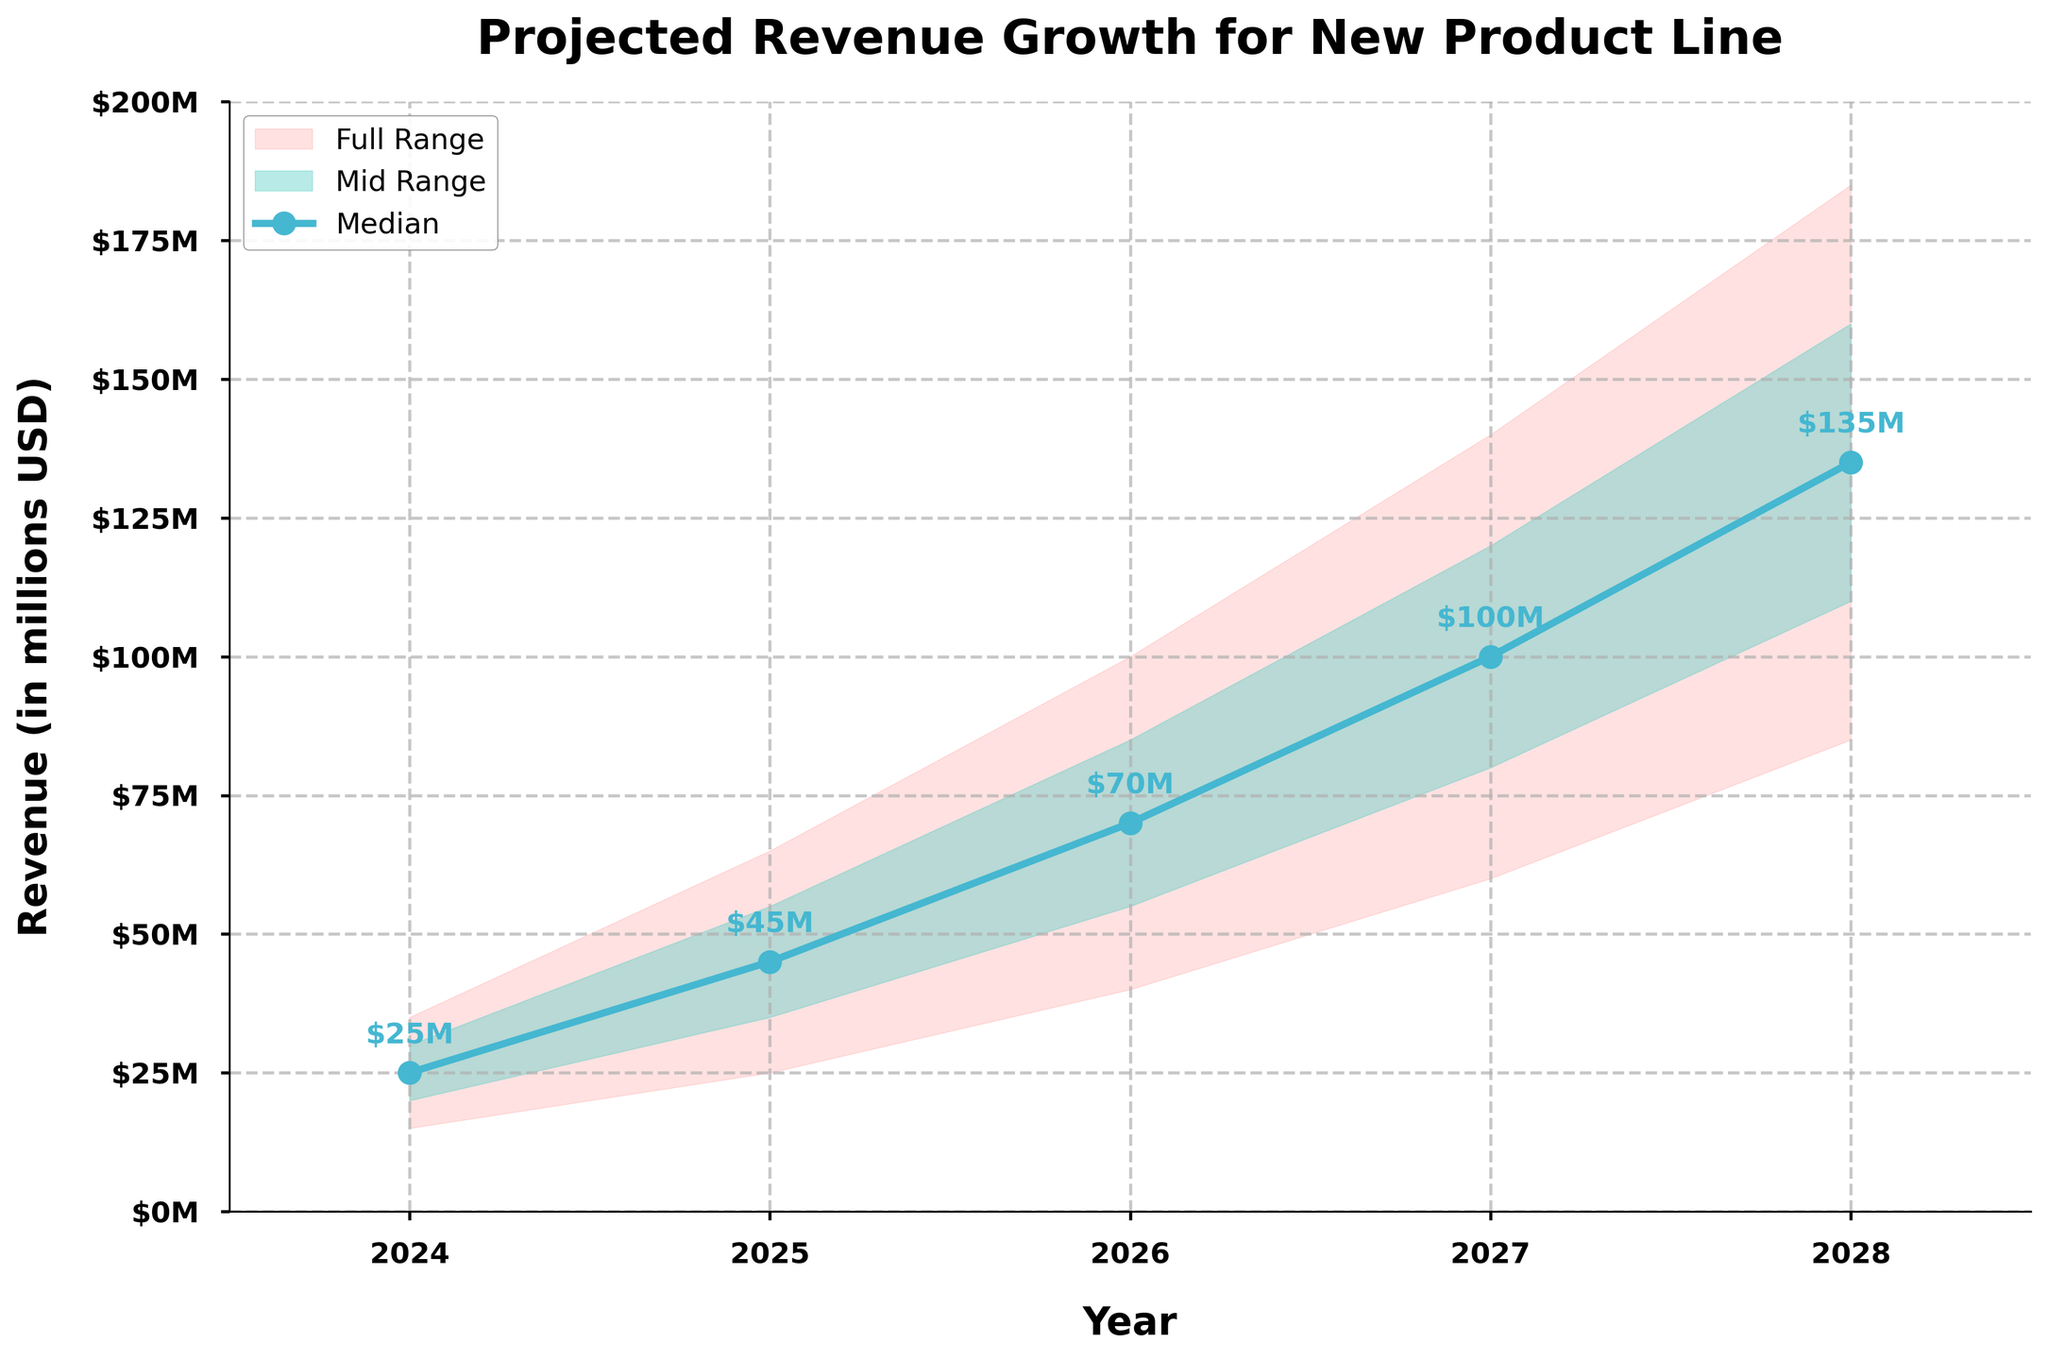what is the highest projected revenue in 2028? The figure shows the projected revenue growth with uncertainty ranges. To find the highest revenue for any given year, we can look at the highest value in the fan chart for that year. For 2028, the highest projected revenue is labeled in the figure, which is 185 million USD.
Answer: 185 million USD what is the mid-range revenue forecast for 2027? The figure has shaded areas representing different ranges of projected revenue. The mid-range is indicated by the brighter shaded area. For 2027, we look at the top and bottom boundaries of this mid-range, which are 80 and 120 million USD respectively.
Answer: 80-120 million USD compare the median projected revenue for 2025 and 2028. Which year has a higher value? To compare the median revenues of two years, we look for the central line marked with dots. For 2025, the median revenue projected is 45 million USD, while for 2028, it is 135 million USD. Clearly, 2028 has a higher median revenue projection.
Answer: 2028 what is the range of possible revenues for 2026? The revenue range for a given year spans from the lowest to the highest boundary of the fan chart. For 2026, the range of possible revenues is from 40 million USD to 100 million USD.
Answer: 40-100 million USD calculate the average of the median projected revenue points over the 5-year period. To find the average median revenue projected over the years, sum the median values for each year and then divide by the number of years. The median values are: 2024 (25M), 2025 (45M), 2026 (70M), 2027 (100M), and 2028 (135M). The sum is 375 million USD, and the average over 5 years would be 375/5 = 75 million USD.
Answer: 75 million USD which year shows the smallest uncertainty range in revenue projections? The uncertainty range is the difference between the highest and lowest projected revenues for a given year. We can determine the year with the smallest range by subtracting the lowest value from the highest for each year and comparing them. After comparing the ranges: 2024 (20M), 2025 (40M), 2026 (60M), 2027 (80M), and 2028 (100M), 2024 has the smallest range of 20 million USD.
Answer: 2024 